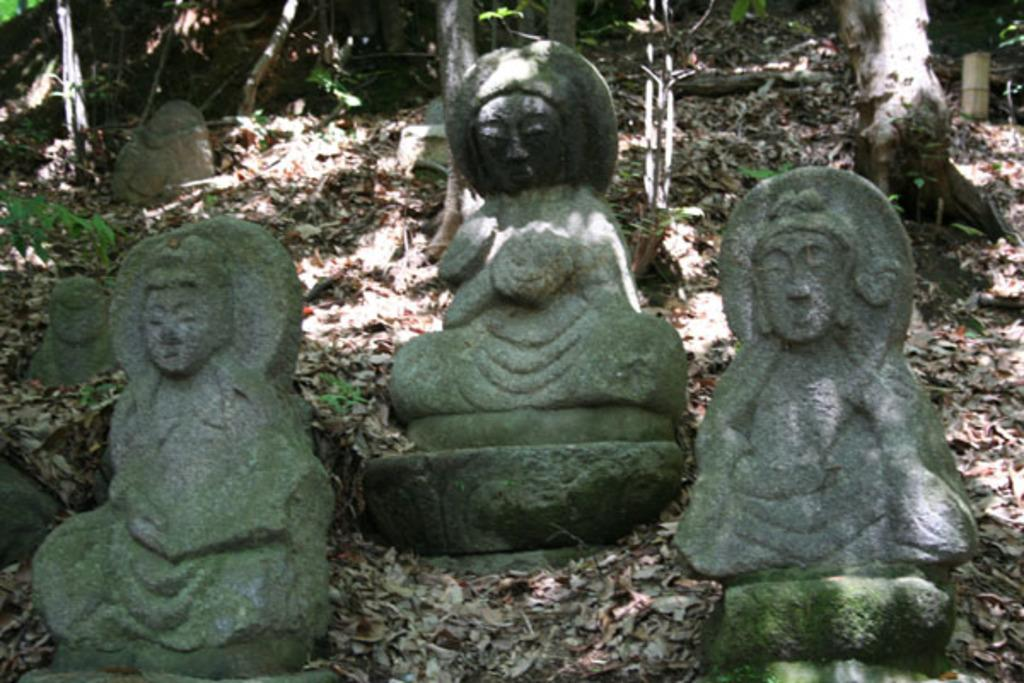What can be seen on the ground in the image? There are statues placed on the ground in the image. What is visible in the background behind the statues? There are trees visible behind the statues. What else is present on the ground in the image? Dried leaves are present on the ground in the image. What type of treatment is being administered to the goose in the image? There is no goose present in the image, so no treatment can be administered. How many cherries are visible on the ground in the image? There are no cherries present in the image. 